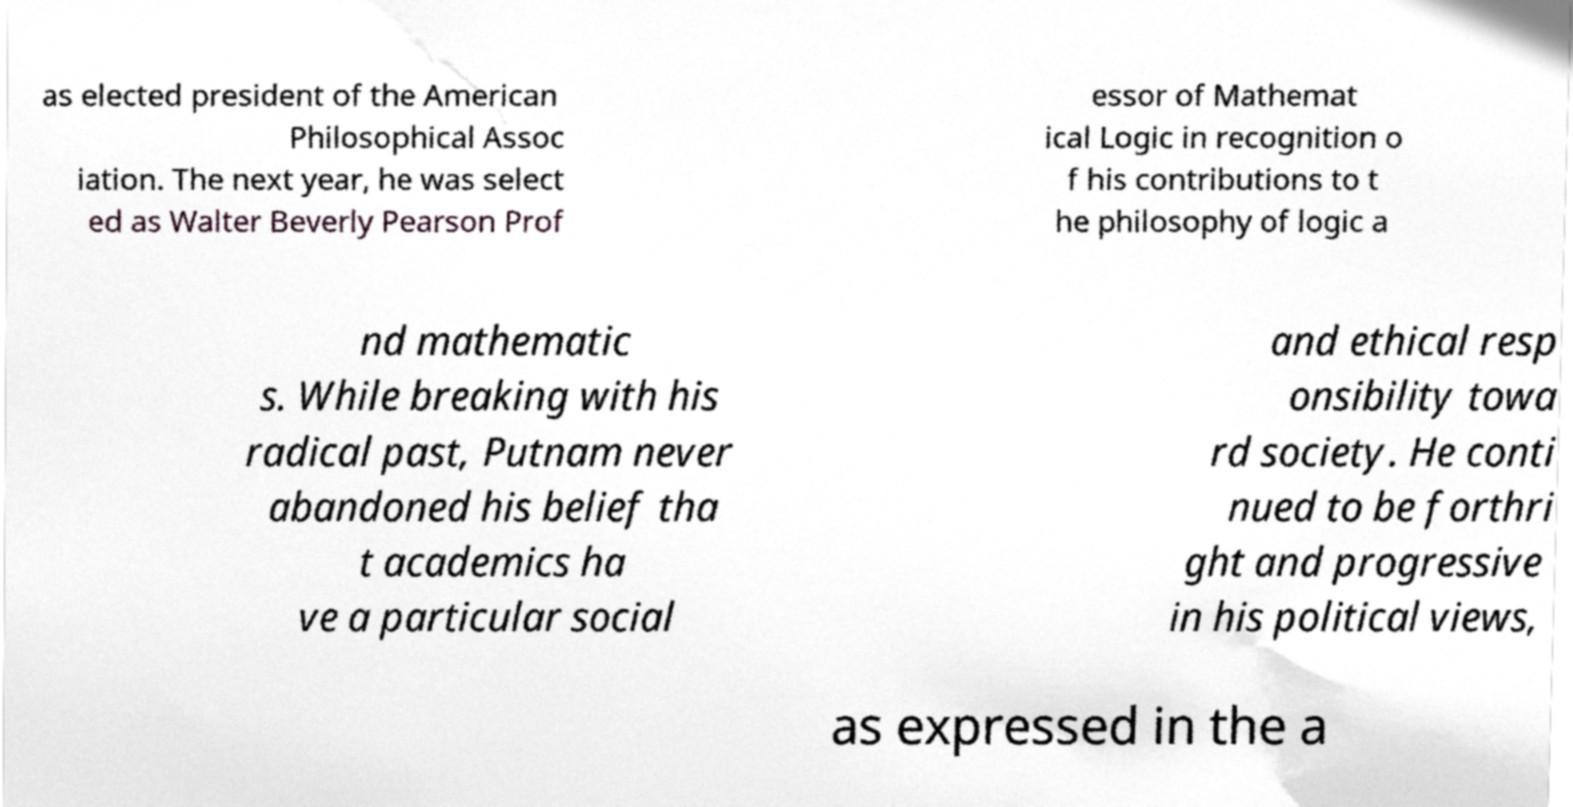Can you read and provide the text displayed in the image?This photo seems to have some interesting text. Can you extract and type it out for me? as elected president of the American Philosophical Assoc iation. The next year, he was select ed as Walter Beverly Pearson Prof essor of Mathemat ical Logic in recognition o f his contributions to t he philosophy of logic a nd mathematic s. While breaking with his radical past, Putnam never abandoned his belief tha t academics ha ve a particular social and ethical resp onsibility towa rd society. He conti nued to be forthri ght and progressive in his political views, as expressed in the a 